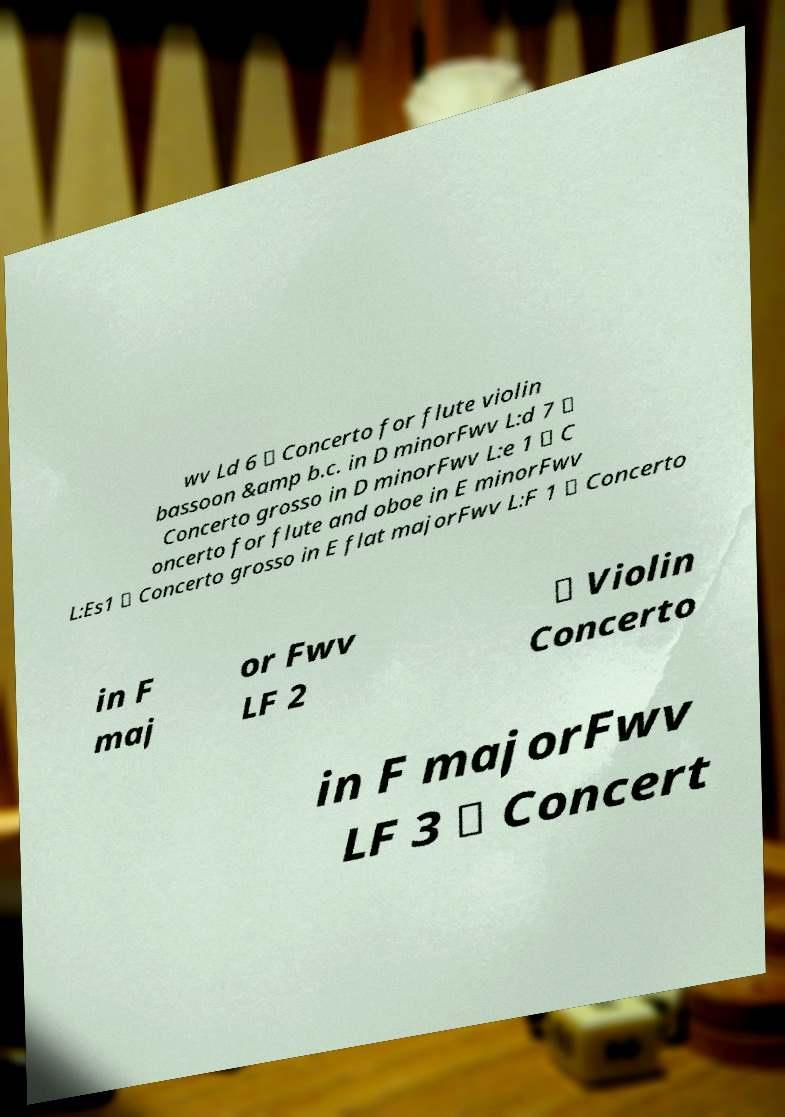What messages or text are displayed in this image? I need them in a readable, typed format. wv Ld 6 \ Concerto for flute violin bassoon &amp b.c. in D minorFwv L:d 7 \ Concerto grosso in D minorFwv L:e 1 \ C oncerto for flute and oboe in E minorFwv L:Es1 \ Concerto grosso in E flat majorFwv L:F 1 \ Concerto in F maj or Fwv LF 2 \ Violin Concerto in F majorFwv LF 3 \ Concert 